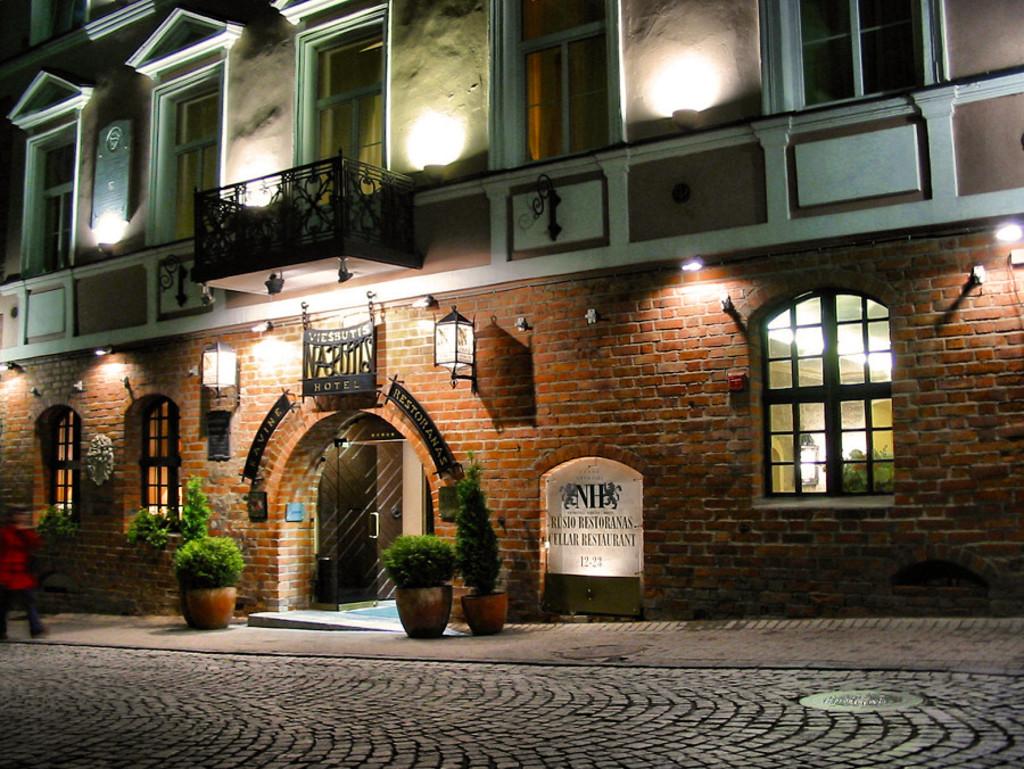Is there a hotel shown in the photo?
Offer a very short reply. Yes. 